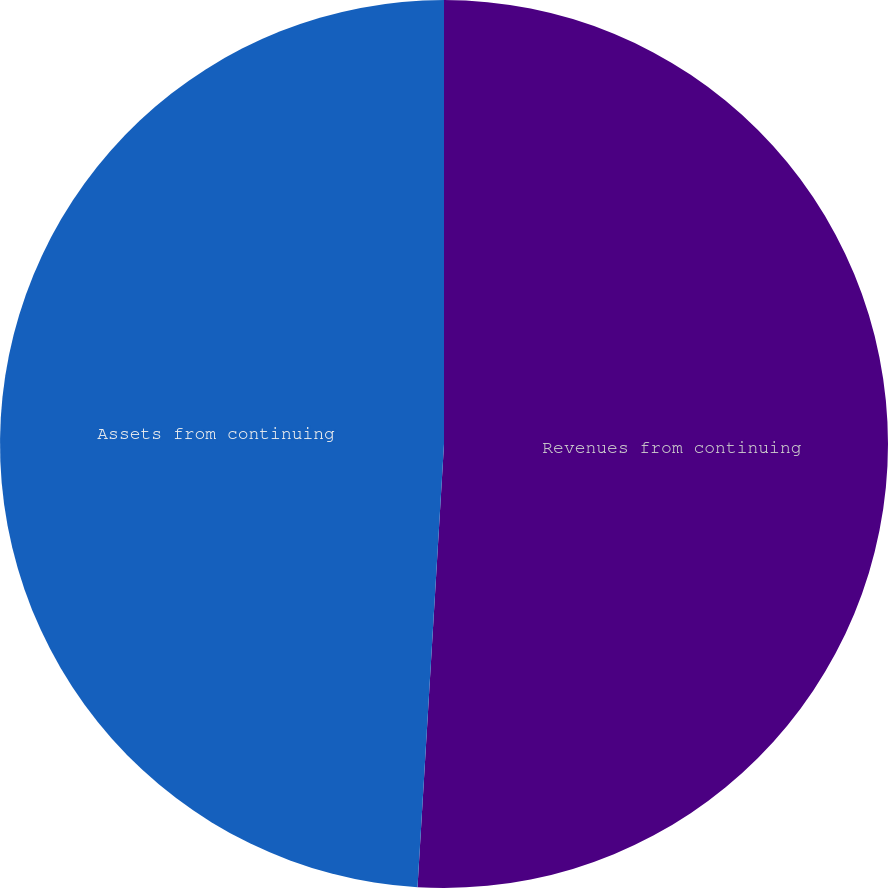Convert chart. <chart><loc_0><loc_0><loc_500><loc_500><pie_chart><fcel>Revenues from continuing<fcel>Assets from continuing<nl><fcel>50.95%<fcel>49.05%<nl></chart> 